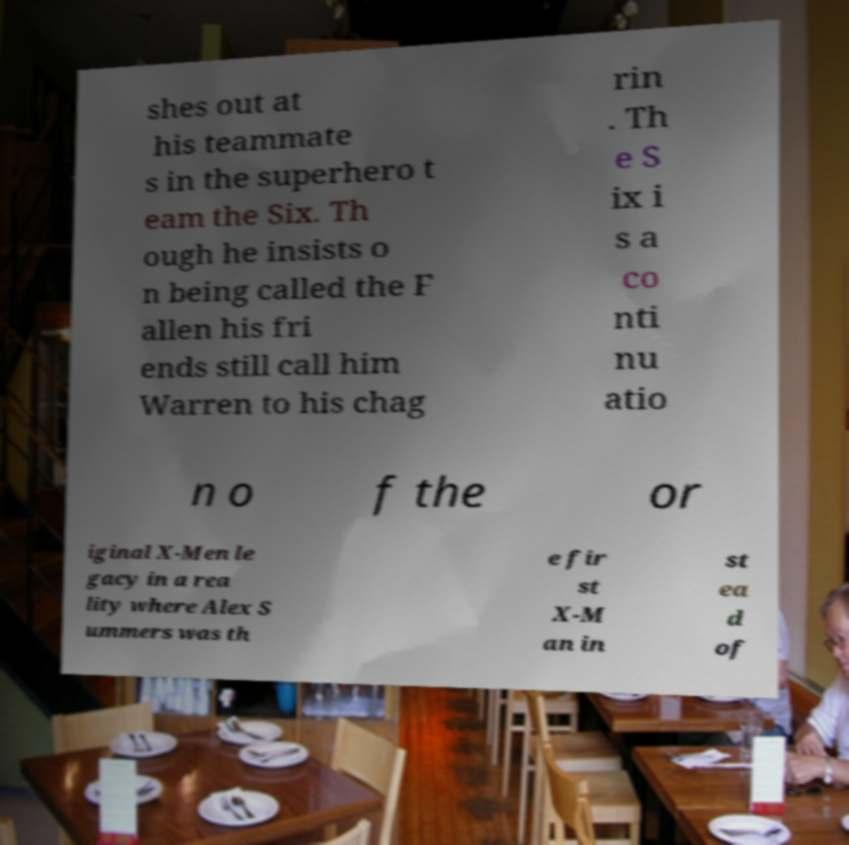Can you accurately transcribe the text from the provided image for me? shes out at his teammate s in the superhero t eam the Six. Th ough he insists o n being called the F allen his fri ends still call him Warren to his chag rin . Th e S ix i s a co nti nu atio n o f the or iginal X-Men le gacy in a rea lity where Alex S ummers was th e fir st X-M an in st ea d of 